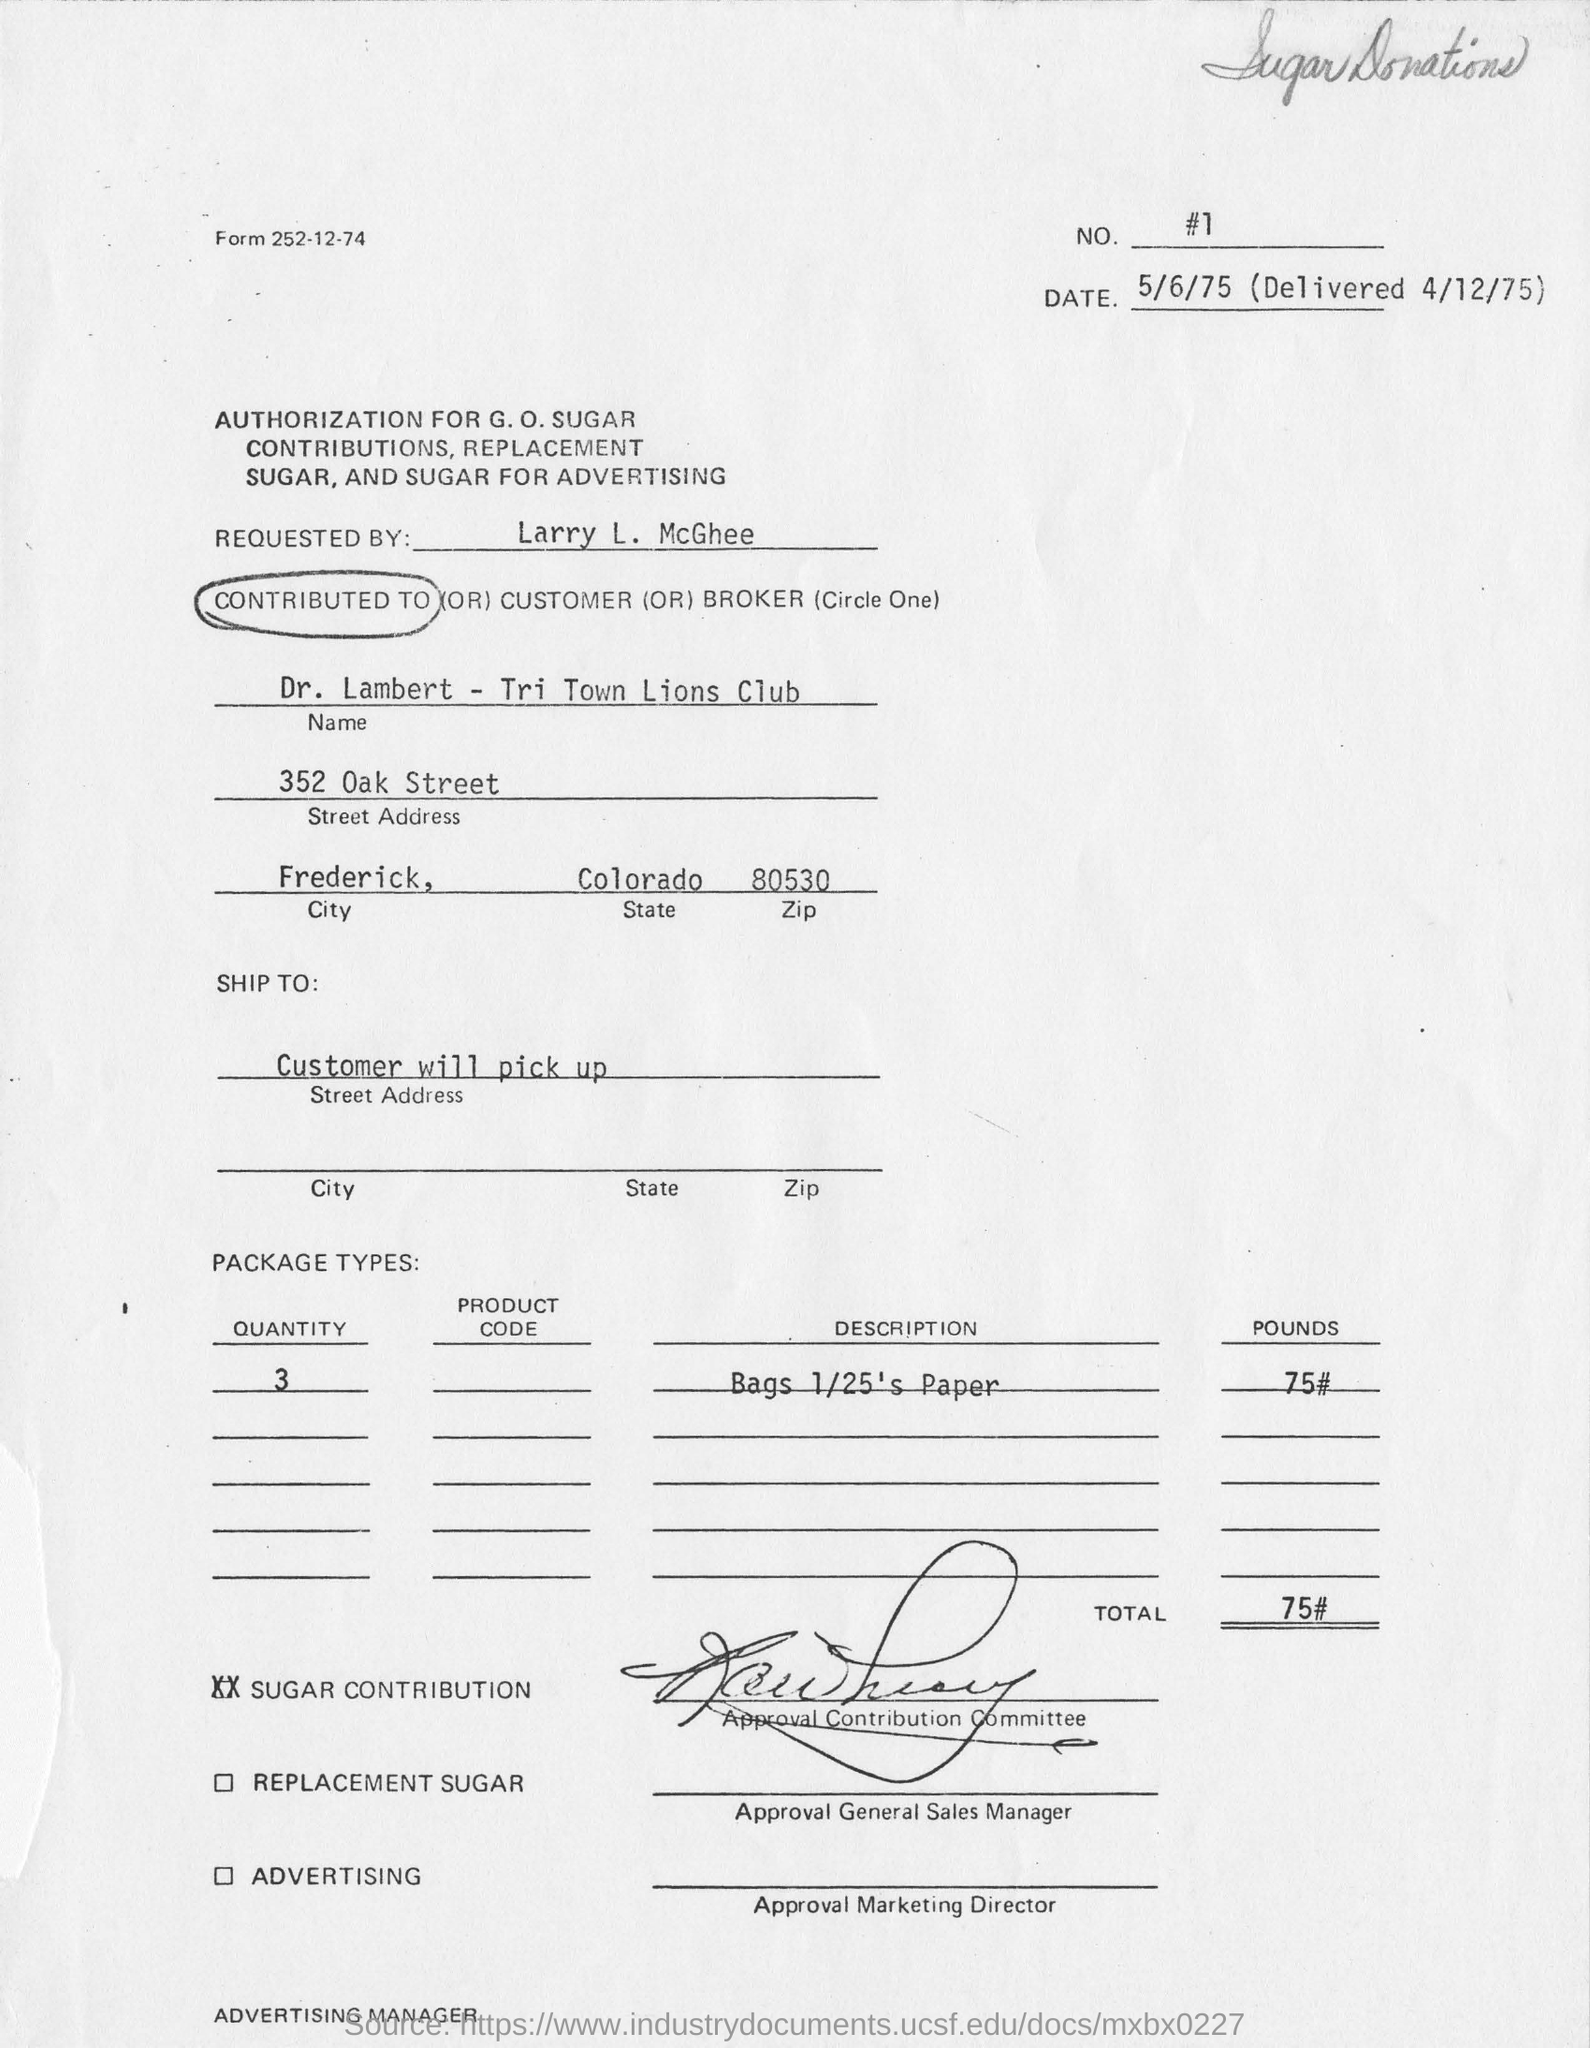Indicate a few pertinent items in this graphic. The authorization for G.O. Sugar contributions has been requested by Larry L. McGhee. The customer will personally collect the package. There will be three packages in total. The weight of the package is 75 pounds. The customer is from Frederick. 